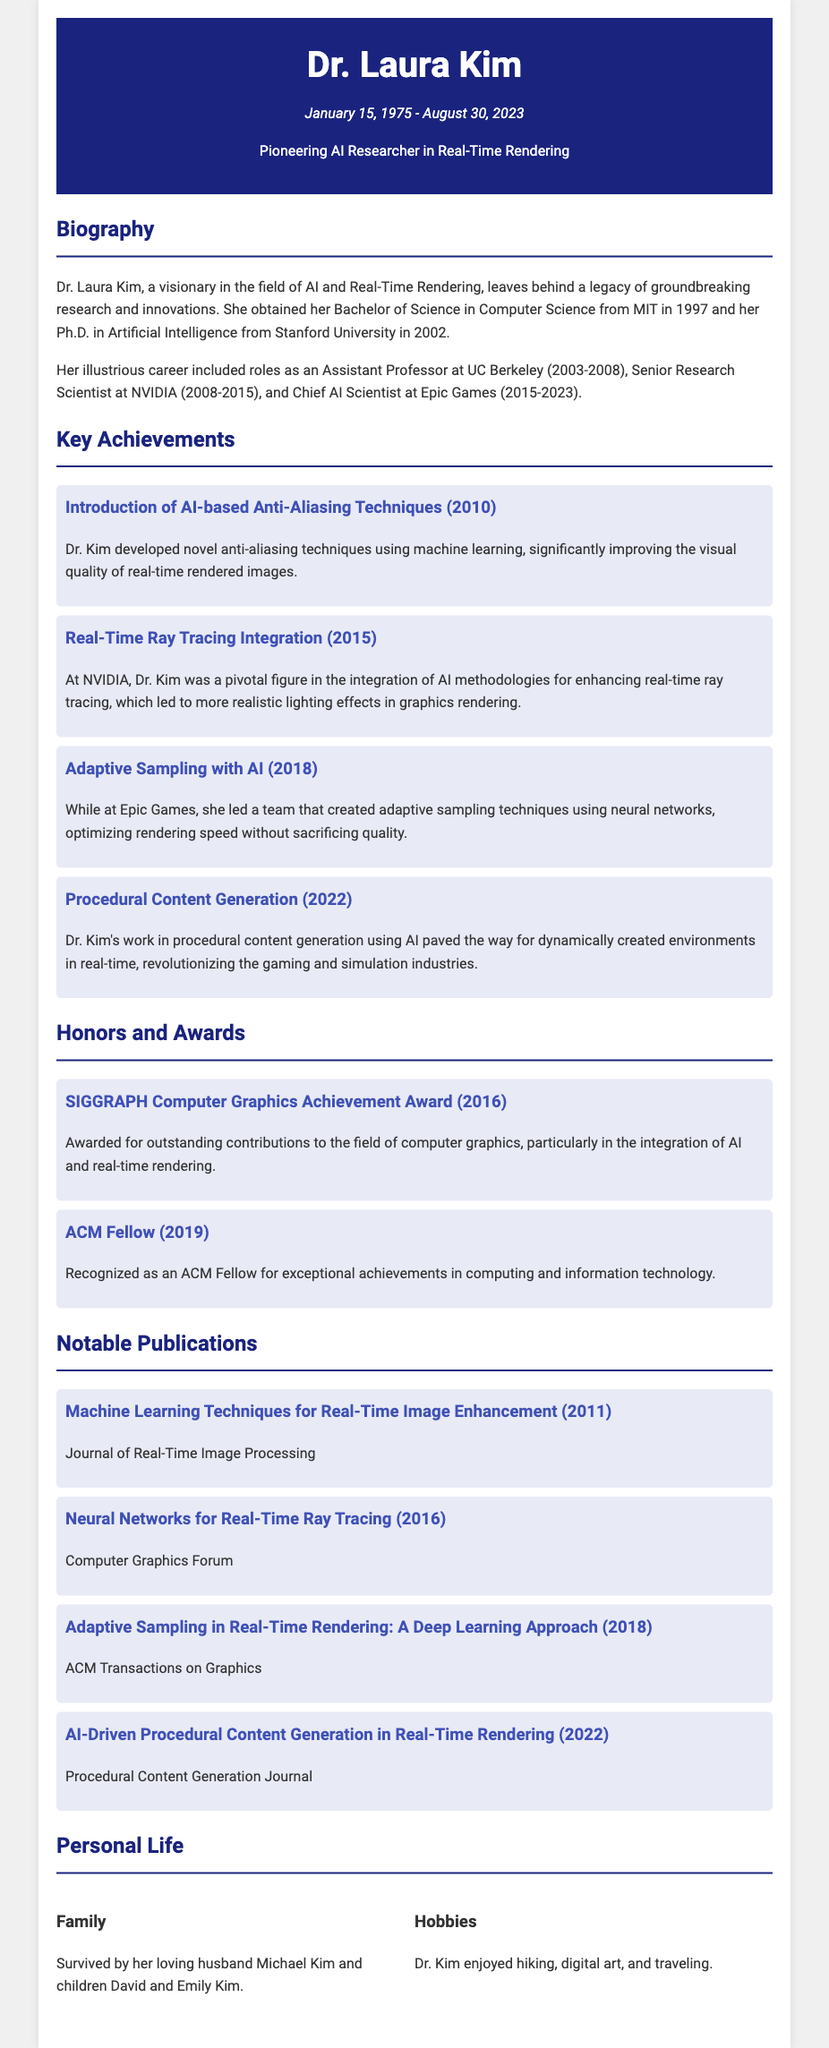What was Dr. Laura Kim's birth date? The birth date of Dr. Laura Kim is mentioned at the beginning of the document, which is January 15, 1975.
Answer: January 15, 1975 When did Dr. Kim obtain her Ph.D.? The document states that Dr. Kim received her Ph.D. in Artificial Intelligence from Stanford University in 2002.
Answer: 2002 Which company did Dr. Kim work for as a Chief AI Scientist? The document explicitly mentions that Dr. Kim worked as Chief AI Scientist at Epic Games.
Answer: Epic Games What honor did Dr. Kim receive in 2016? The document indicates that she received the SIGGRAPH Computer Graphics Achievement Award in 2016 for her contributions to computer graphics.
Answer: SIGGRAPH Computer Graphics Achievement Award What was a significant achievement of Dr. Kim in 2015? The document states that in 2015, Dr. Kim integrated AI methodologies for enhancing real-time ray tracing at NVIDIA.
Answer: Real-Time Ray Tracing Integration What kind of techniques did Dr. Kim develop in 2010? The document mentions that she introduced AI-based anti-aliasing techniques in 2010.
Answer: AI-based Anti-Aliasing Techniques How many children did Dr. Kim have? The document states that she is survived by her children David and Emily Kim, indicating she had two children.
Answer: Two Which university did Dr. Kim attend for her Bachelor's degree? The document notes that she obtained her Bachelor of Science in Computer Science from MIT.
Answer: MIT What was Dr. Kim's profession at UC Berkeley? The document describes her role at UC Berkeley as an Assistant Professor between 2003 and 2008.
Answer: Assistant Professor 